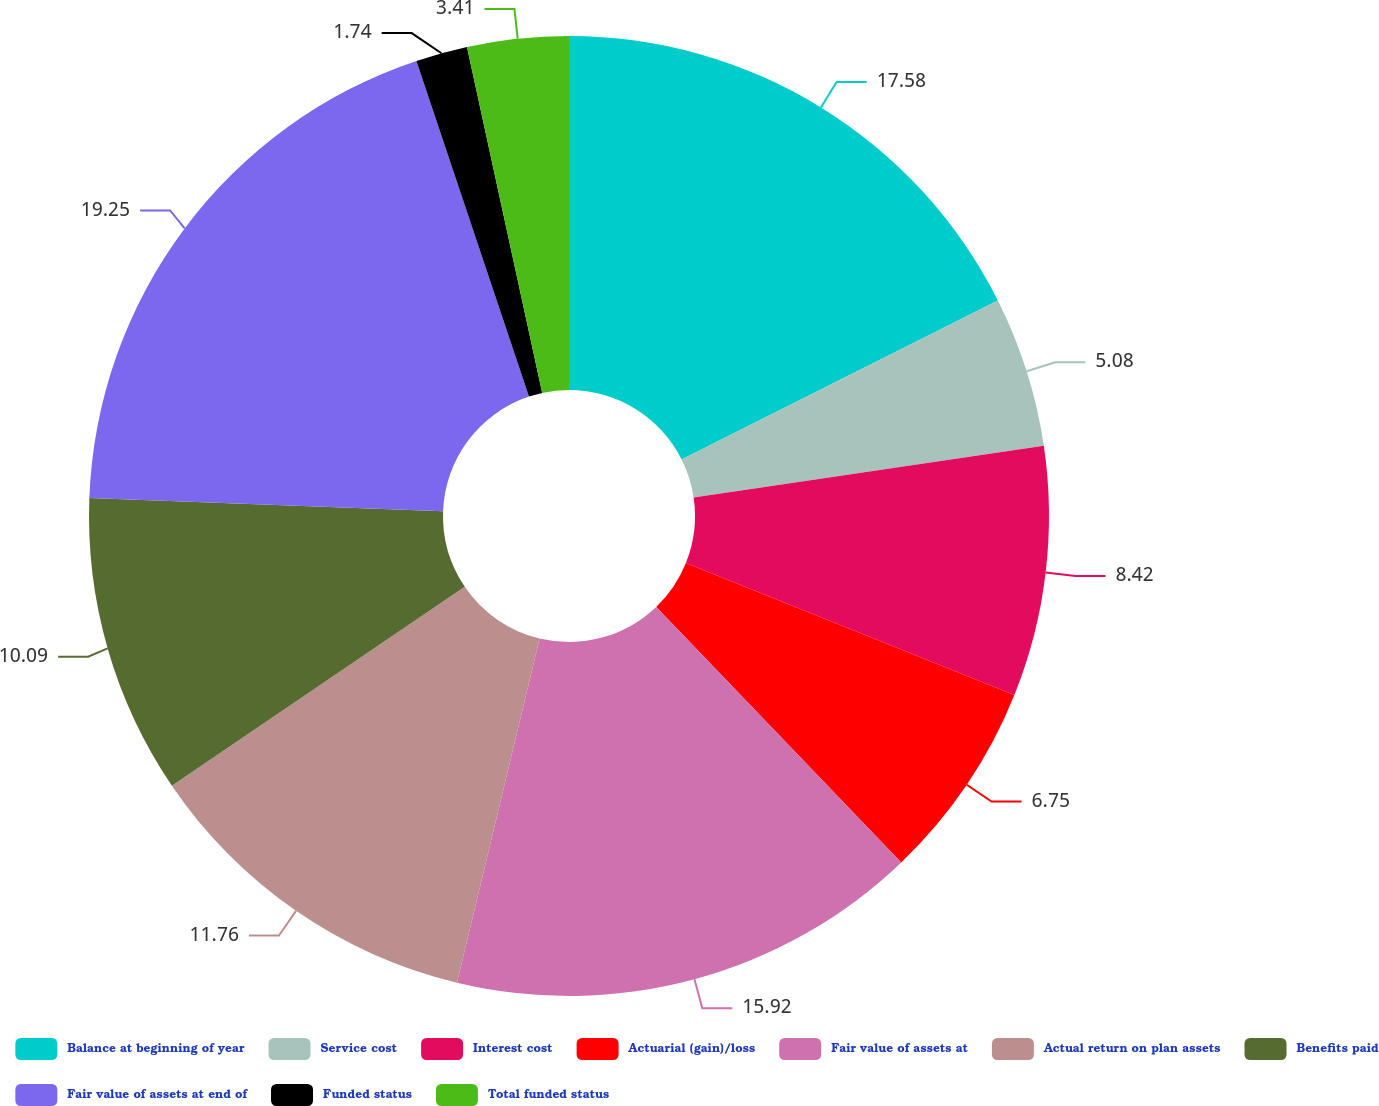Convert chart to OTSL. <chart><loc_0><loc_0><loc_500><loc_500><pie_chart><fcel>Balance at beginning of year<fcel>Service cost<fcel>Interest cost<fcel>Actuarial (gain)/loss<fcel>Fair value of assets at<fcel>Actual return on plan assets<fcel>Benefits paid<fcel>Fair value of assets at end of<fcel>Funded status<fcel>Total funded status<nl><fcel>17.59%<fcel>5.08%<fcel>8.42%<fcel>6.75%<fcel>15.92%<fcel>11.76%<fcel>10.09%<fcel>19.26%<fcel>1.74%<fcel>3.41%<nl></chart> 